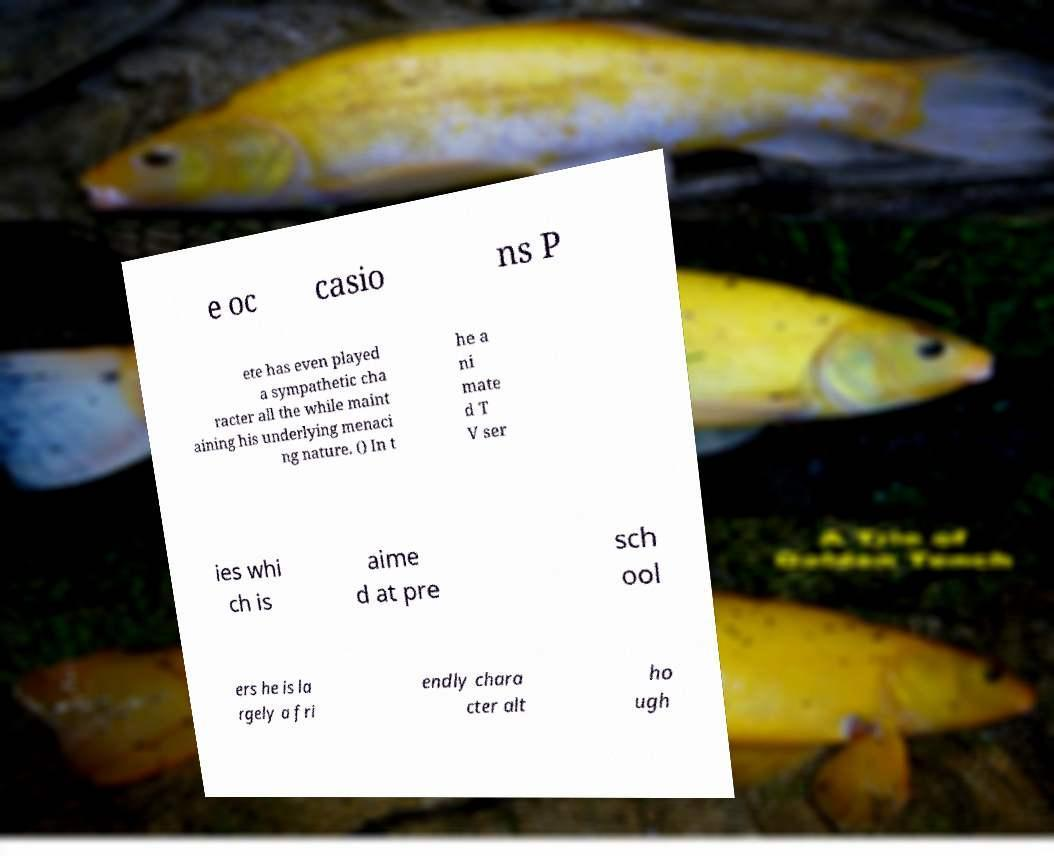I need the written content from this picture converted into text. Can you do that? e oc casio ns P ete has even played a sympathetic cha racter all the while maint aining his underlying menaci ng nature. () In t he a ni mate d T V ser ies whi ch is aime d at pre sch ool ers he is la rgely a fri endly chara cter alt ho ugh 